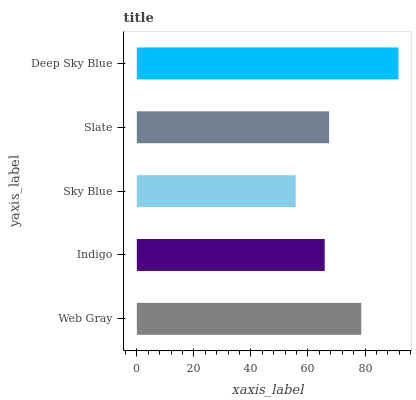Is Sky Blue the minimum?
Answer yes or no. Yes. Is Deep Sky Blue the maximum?
Answer yes or no. Yes. Is Indigo the minimum?
Answer yes or no. No. Is Indigo the maximum?
Answer yes or no. No. Is Web Gray greater than Indigo?
Answer yes or no. Yes. Is Indigo less than Web Gray?
Answer yes or no. Yes. Is Indigo greater than Web Gray?
Answer yes or no. No. Is Web Gray less than Indigo?
Answer yes or no. No. Is Slate the high median?
Answer yes or no. Yes. Is Slate the low median?
Answer yes or no. Yes. Is Sky Blue the high median?
Answer yes or no. No. Is Web Gray the low median?
Answer yes or no. No. 